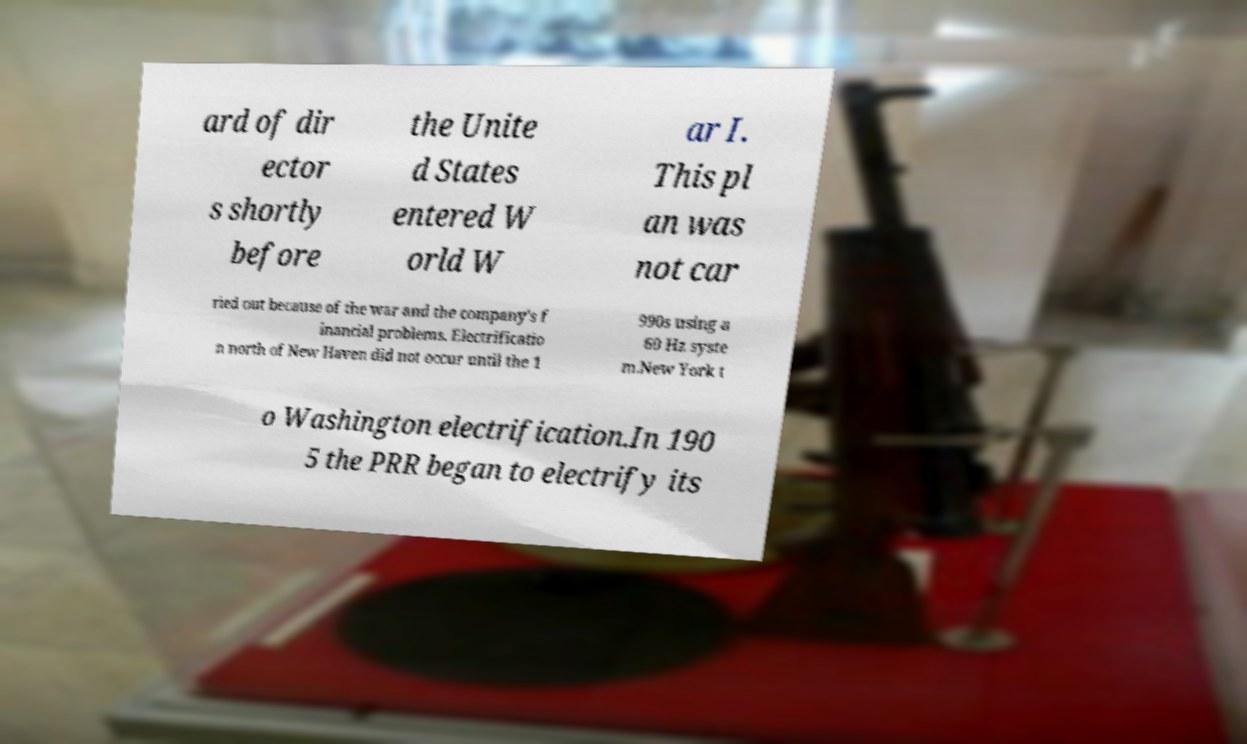There's text embedded in this image that I need extracted. Can you transcribe it verbatim? ard of dir ector s shortly before the Unite d States entered W orld W ar I. This pl an was not car ried out because of the war and the company's f inancial problems. Electrificatio n north of New Haven did not occur until the 1 990s using a 60 Hz syste m.New York t o Washington electrification.In 190 5 the PRR began to electrify its 